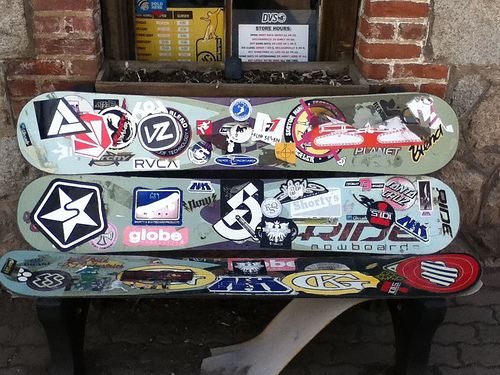<image>
Is there a skateboard next to the skateboard? No. The skateboard is not positioned next to the skateboard. They are located in different areas of the scene. 